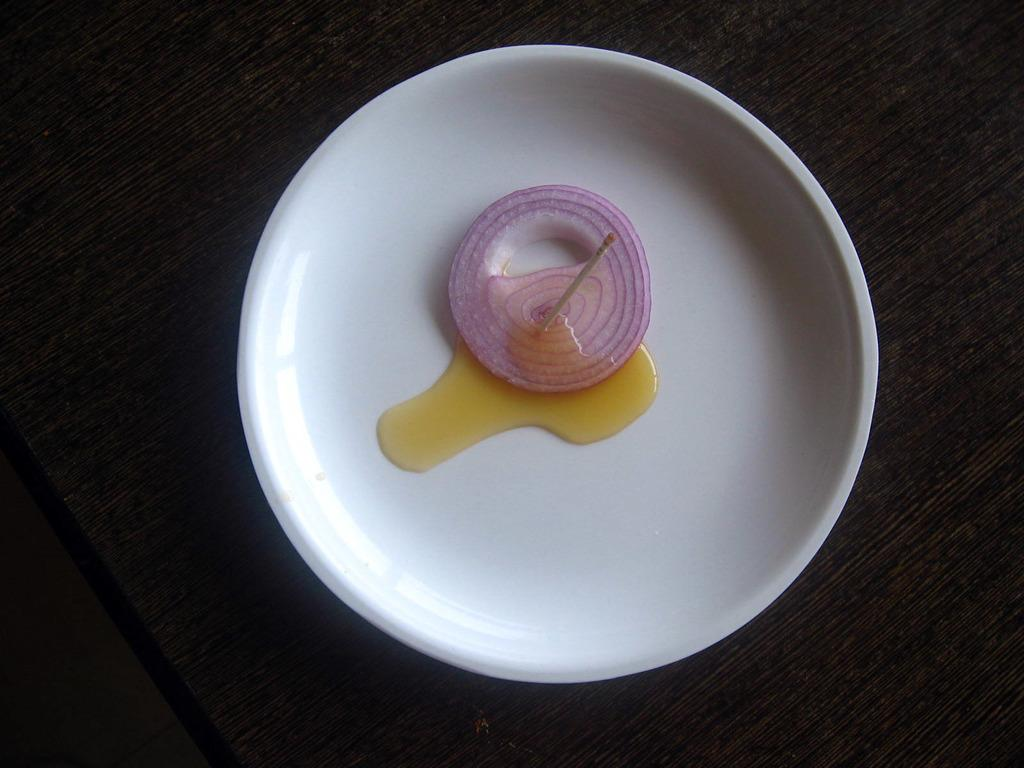What color is the plate in the image? The plate in the image is white. What is the plate placed on? The plate is on a black color surface. What is on top of the plate? There is an onion slice and a toothpick on the plate. Is there any liquid present on the plate? Yes, there is liquid on the plate. What type of flower is growing on the plate in the image? There is no flower present on the plate in the image; it contains an onion slice, a toothpick, and liquid. 